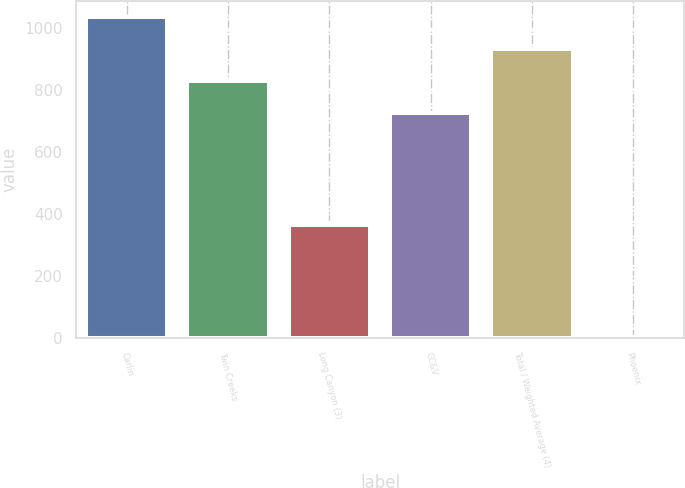<chart> <loc_0><loc_0><loc_500><loc_500><bar_chart><fcel>Carlin<fcel>Twin Creeks<fcel>Long Canyon (3)<fcel>CC&V<fcel>Total / Weighted Average (4)<fcel>Phoenix<nl><fcel>1035<fcel>828.29<fcel>364<fcel>725<fcel>931.58<fcel>2.09<nl></chart> 